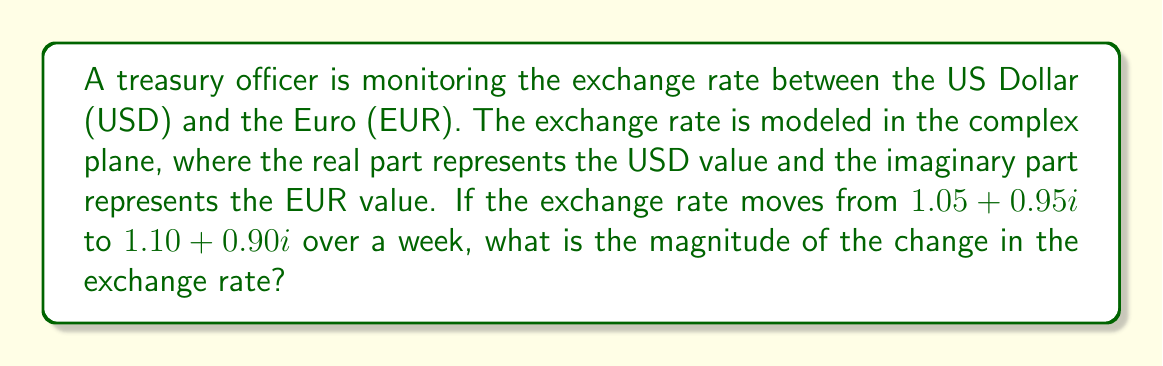Can you solve this math problem? To find the magnitude of the change in the exchange rate, we need to follow these steps:

1) First, we need to calculate the difference between the final and initial exchange rates:
   $$(1.10 + 0.90i) - (1.05 + 0.95i) = (1.10 - 1.05) + (0.90 - 0.95)i = 0.05 - 0.05i$$

2) Now, we have a complex number representing the change: $0.05 - 0.05i$

3) To find the magnitude of this change, we need to calculate the absolute value (or modulus) of this complex number. For a complex number $a + bi$, the magnitude is given by $\sqrt{a^2 + b^2}$

4) In this case:
   $$|0.05 - 0.05i| = \sqrt{(0.05)^2 + (-0.05)^2}$$

5) Simplify:
   $$\sqrt{0.0025 + 0.0025} = \sqrt{0.005}$$

6) Simplify further:
   $$\sqrt{0.005} = \sqrt{\frac{5}{1000}} = \frac{\sqrt{5}}{\sqrt{1000}} = \frac{\sqrt{5}}{10\sqrt{10}} \approx 0.0707$$

Therefore, the magnitude of the change in the exchange rate is $\frac{\sqrt{5}}{10\sqrt{10}}$ or approximately 0.0707.
Answer: $\frac{\sqrt{5}}{10\sqrt{10}}$ 